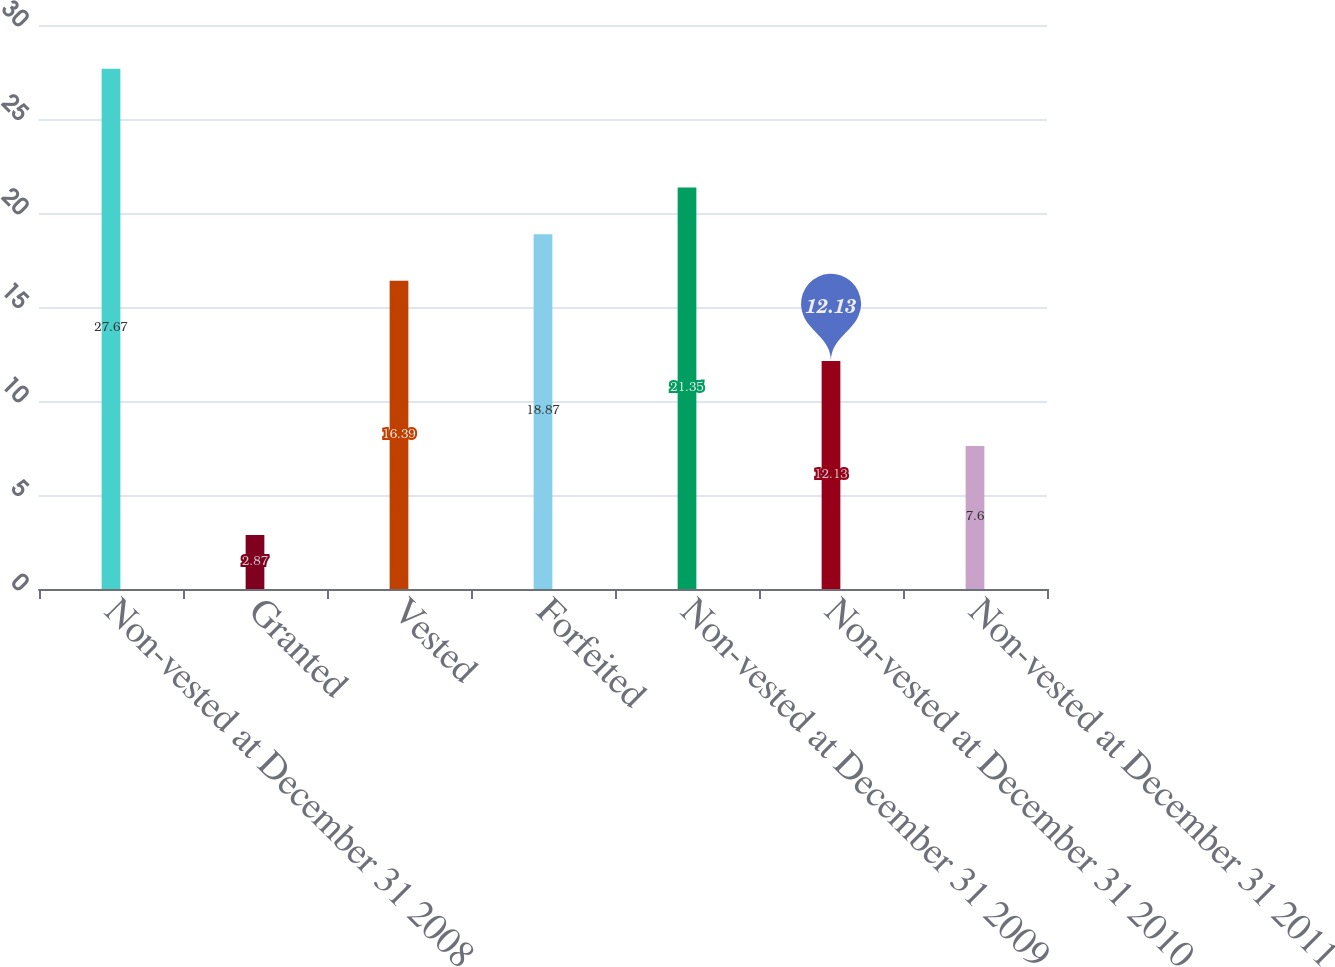Convert chart to OTSL. <chart><loc_0><loc_0><loc_500><loc_500><bar_chart><fcel>Non-vested at December 31 2008<fcel>Granted<fcel>Vested<fcel>Forfeited<fcel>Non-vested at December 31 2009<fcel>Non-vested at December 31 2010<fcel>Non-vested at December 31 2011<nl><fcel>27.67<fcel>2.87<fcel>16.39<fcel>18.87<fcel>21.35<fcel>12.13<fcel>7.6<nl></chart> 